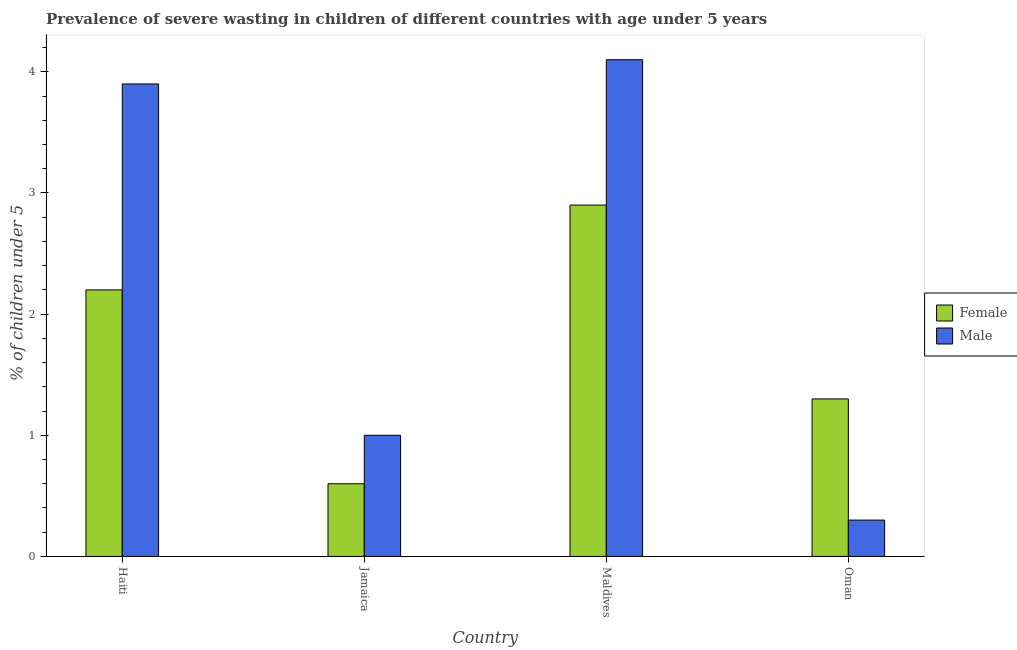Are the number of bars per tick equal to the number of legend labels?
Provide a short and direct response. Yes. Are the number of bars on each tick of the X-axis equal?
Provide a succinct answer. Yes. How many bars are there on the 3rd tick from the right?
Keep it short and to the point. 2. What is the label of the 2nd group of bars from the left?
Ensure brevity in your answer.  Jamaica. What is the percentage of undernourished male children in Oman?
Your answer should be compact. 0.3. Across all countries, what is the maximum percentage of undernourished female children?
Offer a terse response. 2.9. Across all countries, what is the minimum percentage of undernourished female children?
Provide a short and direct response. 0.6. In which country was the percentage of undernourished female children maximum?
Give a very brief answer. Maldives. In which country was the percentage of undernourished male children minimum?
Keep it short and to the point. Oman. What is the total percentage of undernourished female children in the graph?
Your answer should be compact. 7. What is the difference between the percentage of undernourished female children in Maldives and that in Oman?
Offer a terse response. 1.6. What is the difference between the percentage of undernourished female children in Maldives and the percentage of undernourished male children in Jamaica?
Provide a succinct answer. 1.9. What is the average percentage of undernourished female children per country?
Make the answer very short. 1.75. What is the difference between the percentage of undernourished female children and percentage of undernourished male children in Oman?
Provide a short and direct response. 1. What is the ratio of the percentage of undernourished male children in Maldives to that in Oman?
Your answer should be compact. 13.67. Is the difference between the percentage of undernourished male children in Haiti and Maldives greater than the difference between the percentage of undernourished female children in Haiti and Maldives?
Give a very brief answer. Yes. What is the difference between the highest and the second highest percentage of undernourished female children?
Ensure brevity in your answer.  0.7. What is the difference between the highest and the lowest percentage of undernourished female children?
Ensure brevity in your answer.  2.3. Is the sum of the percentage of undernourished male children in Haiti and Oman greater than the maximum percentage of undernourished female children across all countries?
Ensure brevity in your answer.  Yes. What does the 2nd bar from the left in Haiti represents?
Your response must be concise. Male. What does the 1st bar from the right in Maldives represents?
Offer a very short reply. Male. Where does the legend appear in the graph?
Give a very brief answer. Center right. What is the title of the graph?
Give a very brief answer. Prevalence of severe wasting in children of different countries with age under 5 years. What is the label or title of the Y-axis?
Give a very brief answer.  % of children under 5. What is the  % of children under 5 in Female in Haiti?
Make the answer very short. 2.2. What is the  % of children under 5 of Male in Haiti?
Give a very brief answer. 3.9. What is the  % of children under 5 in Female in Jamaica?
Keep it short and to the point. 0.6. What is the  % of children under 5 of Female in Maldives?
Offer a terse response. 2.9. What is the  % of children under 5 of Male in Maldives?
Provide a short and direct response. 4.1. What is the  % of children under 5 in Female in Oman?
Your response must be concise. 1.3. What is the  % of children under 5 in Male in Oman?
Your answer should be compact. 0.3. Across all countries, what is the maximum  % of children under 5 in Female?
Ensure brevity in your answer.  2.9. Across all countries, what is the maximum  % of children under 5 in Male?
Keep it short and to the point. 4.1. Across all countries, what is the minimum  % of children under 5 in Female?
Make the answer very short. 0.6. Across all countries, what is the minimum  % of children under 5 of Male?
Offer a terse response. 0.3. What is the total  % of children under 5 of Female in the graph?
Ensure brevity in your answer.  7. What is the total  % of children under 5 of Male in the graph?
Ensure brevity in your answer.  9.3. What is the difference between the  % of children under 5 of Female in Haiti and that in Jamaica?
Make the answer very short. 1.6. What is the difference between the  % of children under 5 of Female in Haiti and that in Maldives?
Provide a succinct answer. -0.7. What is the difference between the  % of children under 5 in Male in Haiti and that in Maldives?
Your answer should be very brief. -0.2. What is the difference between the  % of children under 5 of Male in Haiti and that in Oman?
Your answer should be compact. 3.6. What is the difference between the  % of children under 5 in Female in Jamaica and that in Maldives?
Provide a succinct answer. -2.3. What is the difference between the  % of children under 5 of Female in Jamaica and that in Oman?
Keep it short and to the point. -0.7. What is the difference between the  % of children under 5 of Female in Maldives and that in Oman?
Keep it short and to the point. 1.6. What is the difference between the  % of children under 5 in Female in Haiti and the  % of children under 5 in Male in Jamaica?
Give a very brief answer. 1.2. What is the difference between the  % of children under 5 in Female in Haiti and the  % of children under 5 in Male in Oman?
Offer a very short reply. 1.9. What is the difference between the  % of children under 5 of Female in Jamaica and the  % of children under 5 of Male in Maldives?
Keep it short and to the point. -3.5. What is the difference between the  % of children under 5 in Female in Jamaica and the  % of children under 5 in Male in Oman?
Your answer should be very brief. 0.3. What is the average  % of children under 5 in Female per country?
Ensure brevity in your answer.  1.75. What is the average  % of children under 5 of Male per country?
Offer a very short reply. 2.33. What is the ratio of the  % of children under 5 in Female in Haiti to that in Jamaica?
Offer a terse response. 3.67. What is the ratio of the  % of children under 5 of Female in Haiti to that in Maldives?
Your response must be concise. 0.76. What is the ratio of the  % of children under 5 in Male in Haiti to that in Maldives?
Give a very brief answer. 0.95. What is the ratio of the  % of children under 5 of Female in Haiti to that in Oman?
Offer a terse response. 1.69. What is the ratio of the  % of children under 5 of Female in Jamaica to that in Maldives?
Your answer should be compact. 0.21. What is the ratio of the  % of children under 5 in Male in Jamaica to that in Maldives?
Your answer should be very brief. 0.24. What is the ratio of the  % of children under 5 in Female in Jamaica to that in Oman?
Ensure brevity in your answer.  0.46. What is the ratio of the  % of children under 5 of Male in Jamaica to that in Oman?
Give a very brief answer. 3.33. What is the ratio of the  % of children under 5 of Female in Maldives to that in Oman?
Ensure brevity in your answer.  2.23. What is the ratio of the  % of children under 5 of Male in Maldives to that in Oman?
Provide a succinct answer. 13.67. What is the difference between the highest and the second highest  % of children under 5 in Female?
Keep it short and to the point. 0.7. What is the difference between the highest and the lowest  % of children under 5 of Female?
Your answer should be very brief. 2.3. What is the difference between the highest and the lowest  % of children under 5 in Male?
Keep it short and to the point. 3.8. 